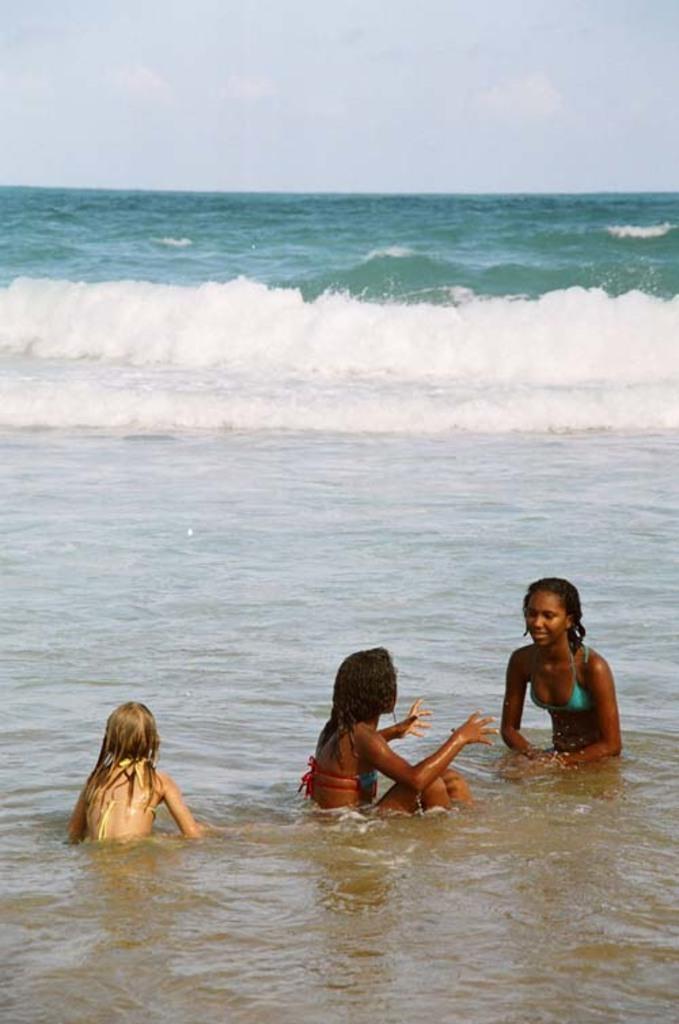Can you describe this image briefly? In this image we can see people in water. In the background there is a sea and sky. 